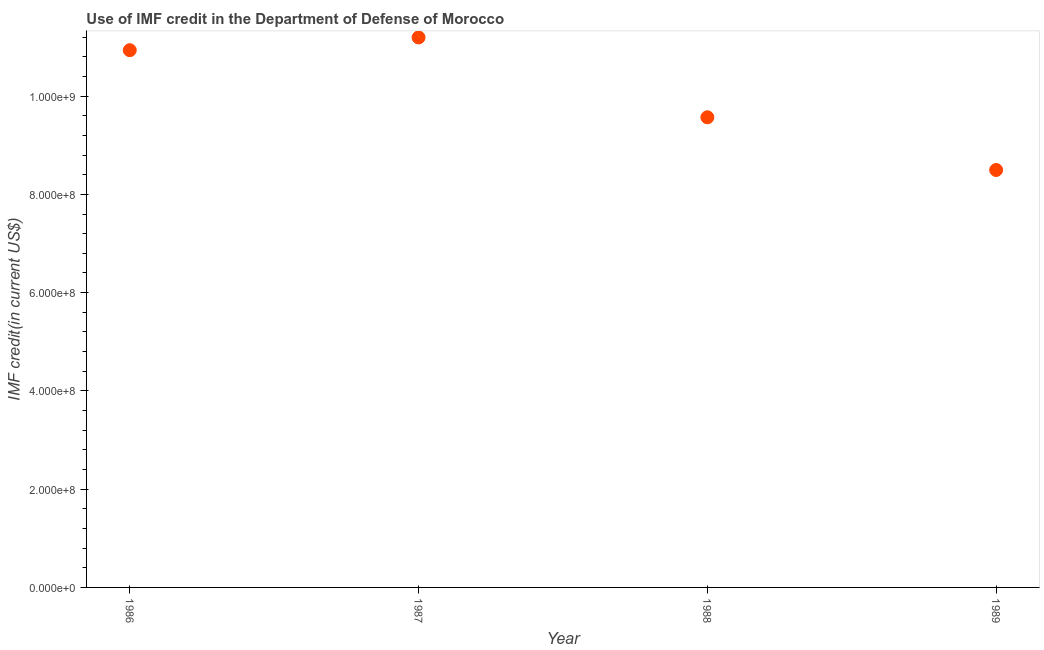What is the use of imf credit in dod in 1988?
Make the answer very short. 9.57e+08. Across all years, what is the maximum use of imf credit in dod?
Keep it short and to the point. 1.12e+09. Across all years, what is the minimum use of imf credit in dod?
Your answer should be very brief. 8.50e+08. In which year was the use of imf credit in dod minimum?
Keep it short and to the point. 1989. What is the sum of the use of imf credit in dod?
Your answer should be compact. 4.02e+09. What is the difference between the use of imf credit in dod in 1986 and 1987?
Your answer should be very brief. -2.59e+07. What is the average use of imf credit in dod per year?
Your answer should be very brief. 1.00e+09. What is the median use of imf credit in dod?
Offer a very short reply. 1.03e+09. What is the ratio of the use of imf credit in dod in 1988 to that in 1989?
Your answer should be very brief. 1.13. Is the use of imf credit in dod in 1987 less than that in 1988?
Ensure brevity in your answer.  No. What is the difference between the highest and the second highest use of imf credit in dod?
Ensure brevity in your answer.  2.59e+07. What is the difference between the highest and the lowest use of imf credit in dod?
Provide a succinct answer. 2.70e+08. In how many years, is the use of imf credit in dod greater than the average use of imf credit in dod taken over all years?
Ensure brevity in your answer.  2. Does the graph contain any zero values?
Your answer should be compact. No. Does the graph contain grids?
Offer a very short reply. No. What is the title of the graph?
Provide a succinct answer. Use of IMF credit in the Department of Defense of Morocco. What is the label or title of the Y-axis?
Offer a very short reply. IMF credit(in current US$). What is the IMF credit(in current US$) in 1986?
Your answer should be compact. 1.09e+09. What is the IMF credit(in current US$) in 1987?
Make the answer very short. 1.12e+09. What is the IMF credit(in current US$) in 1988?
Provide a short and direct response. 9.57e+08. What is the IMF credit(in current US$) in 1989?
Ensure brevity in your answer.  8.50e+08. What is the difference between the IMF credit(in current US$) in 1986 and 1987?
Your answer should be very brief. -2.59e+07. What is the difference between the IMF credit(in current US$) in 1986 and 1988?
Your answer should be compact. 1.37e+08. What is the difference between the IMF credit(in current US$) in 1986 and 1989?
Your answer should be compact. 2.44e+08. What is the difference between the IMF credit(in current US$) in 1987 and 1988?
Give a very brief answer. 1.63e+08. What is the difference between the IMF credit(in current US$) in 1987 and 1989?
Make the answer very short. 2.70e+08. What is the difference between the IMF credit(in current US$) in 1988 and 1989?
Offer a very short reply. 1.07e+08. What is the ratio of the IMF credit(in current US$) in 1986 to that in 1987?
Ensure brevity in your answer.  0.98. What is the ratio of the IMF credit(in current US$) in 1986 to that in 1988?
Provide a succinct answer. 1.14. What is the ratio of the IMF credit(in current US$) in 1986 to that in 1989?
Ensure brevity in your answer.  1.29. What is the ratio of the IMF credit(in current US$) in 1987 to that in 1988?
Your response must be concise. 1.17. What is the ratio of the IMF credit(in current US$) in 1987 to that in 1989?
Keep it short and to the point. 1.32. What is the ratio of the IMF credit(in current US$) in 1988 to that in 1989?
Provide a succinct answer. 1.13. 